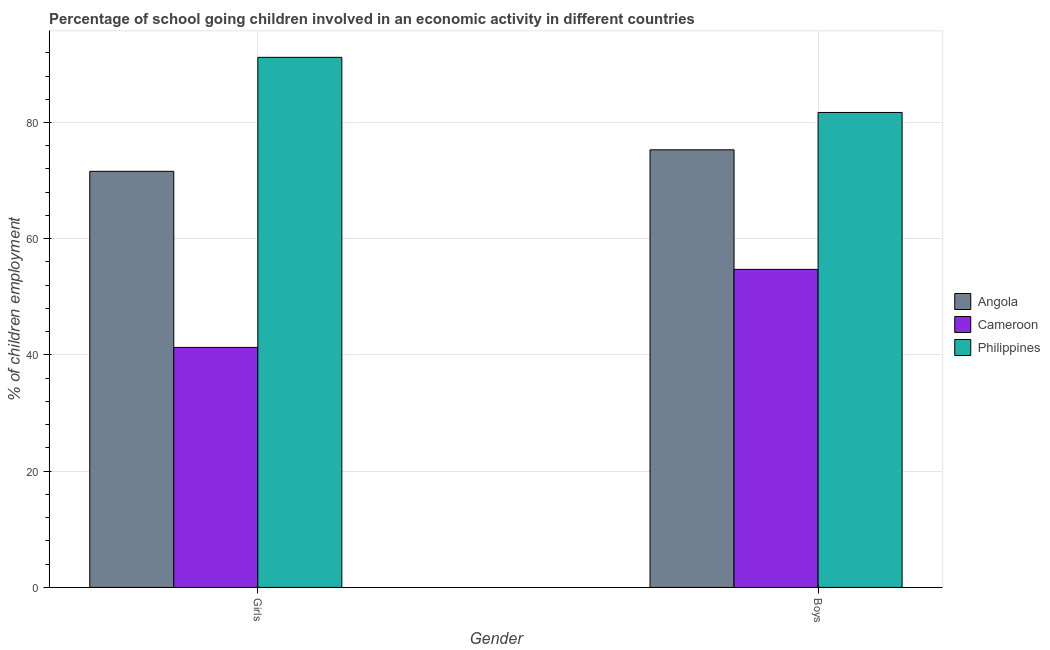How many different coloured bars are there?
Provide a short and direct response. 3. Are the number of bars per tick equal to the number of legend labels?
Your response must be concise. Yes. Are the number of bars on each tick of the X-axis equal?
Your response must be concise. Yes. How many bars are there on the 1st tick from the left?
Provide a short and direct response. 3. What is the label of the 2nd group of bars from the left?
Offer a terse response. Boys. What is the percentage of school going girls in Angola?
Your response must be concise. 71.6. Across all countries, what is the maximum percentage of school going girls?
Offer a very short reply. 91.21. Across all countries, what is the minimum percentage of school going boys?
Keep it short and to the point. 54.73. In which country was the percentage of school going boys minimum?
Give a very brief answer. Cameroon. What is the total percentage of school going boys in the graph?
Provide a succinct answer. 211.76. What is the difference between the percentage of school going boys in Philippines and that in Angola?
Give a very brief answer. 6.43. What is the difference between the percentage of school going boys in Angola and the percentage of school going girls in Cameroon?
Provide a succinct answer. 34. What is the average percentage of school going boys per country?
Your answer should be compact. 70.59. What is the difference between the percentage of school going boys and percentage of school going girls in Cameroon?
Keep it short and to the point. 13.43. What is the ratio of the percentage of school going boys in Cameroon to that in Angola?
Ensure brevity in your answer.  0.73. In how many countries, is the percentage of school going girls greater than the average percentage of school going girls taken over all countries?
Make the answer very short. 2. What does the 1st bar from the left in Boys represents?
Offer a terse response. Angola. What does the 3rd bar from the right in Girls represents?
Keep it short and to the point. Angola. Are all the bars in the graph horizontal?
Ensure brevity in your answer.  No. How many countries are there in the graph?
Make the answer very short. 3. Does the graph contain grids?
Provide a succinct answer. Yes. Where does the legend appear in the graph?
Keep it short and to the point. Center right. How many legend labels are there?
Provide a short and direct response. 3. How are the legend labels stacked?
Offer a terse response. Vertical. What is the title of the graph?
Ensure brevity in your answer.  Percentage of school going children involved in an economic activity in different countries. Does "Least developed countries" appear as one of the legend labels in the graph?
Provide a short and direct response. No. What is the label or title of the Y-axis?
Give a very brief answer. % of children employment. What is the % of children employment in Angola in Girls?
Provide a short and direct response. 71.6. What is the % of children employment in Cameroon in Girls?
Make the answer very short. 41.3. What is the % of children employment in Philippines in Girls?
Your response must be concise. 91.21. What is the % of children employment of Angola in Boys?
Your response must be concise. 75.3. What is the % of children employment of Cameroon in Boys?
Your answer should be compact. 54.73. What is the % of children employment of Philippines in Boys?
Ensure brevity in your answer.  81.73. Across all Gender, what is the maximum % of children employment of Angola?
Provide a succinct answer. 75.3. Across all Gender, what is the maximum % of children employment of Cameroon?
Offer a terse response. 54.73. Across all Gender, what is the maximum % of children employment of Philippines?
Keep it short and to the point. 91.21. Across all Gender, what is the minimum % of children employment in Angola?
Make the answer very short. 71.6. Across all Gender, what is the minimum % of children employment in Cameroon?
Provide a short and direct response. 41.3. Across all Gender, what is the minimum % of children employment in Philippines?
Offer a very short reply. 81.73. What is the total % of children employment in Angola in the graph?
Your answer should be very brief. 146.9. What is the total % of children employment in Cameroon in the graph?
Offer a terse response. 96.03. What is the total % of children employment of Philippines in the graph?
Your answer should be compact. 172.94. What is the difference between the % of children employment of Cameroon in Girls and that in Boys?
Keep it short and to the point. -13.43. What is the difference between the % of children employment in Philippines in Girls and that in Boys?
Give a very brief answer. 9.49. What is the difference between the % of children employment in Angola in Girls and the % of children employment in Cameroon in Boys?
Ensure brevity in your answer.  16.87. What is the difference between the % of children employment of Angola in Girls and the % of children employment of Philippines in Boys?
Your response must be concise. -10.13. What is the difference between the % of children employment in Cameroon in Girls and the % of children employment in Philippines in Boys?
Your answer should be compact. -40.43. What is the average % of children employment of Angola per Gender?
Keep it short and to the point. 73.45. What is the average % of children employment in Cameroon per Gender?
Offer a very short reply. 48.01. What is the average % of children employment in Philippines per Gender?
Provide a short and direct response. 86.47. What is the difference between the % of children employment in Angola and % of children employment in Cameroon in Girls?
Your answer should be very brief. 30.3. What is the difference between the % of children employment of Angola and % of children employment of Philippines in Girls?
Your answer should be compact. -19.61. What is the difference between the % of children employment of Cameroon and % of children employment of Philippines in Girls?
Ensure brevity in your answer.  -49.92. What is the difference between the % of children employment of Angola and % of children employment of Cameroon in Boys?
Provide a succinct answer. 20.57. What is the difference between the % of children employment in Angola and % of children employment in Philippines in Boys?
Your answer should be very brief. -6.43. What is the difference between the % of children employment in Cameroon and % of children employment in Philippines in Boys?
Provide a succinct answer. -27. What is the ratio of the % of children employment of Angola in Girls to that in Boys?
Offer a terse response. 0.95. What is the ratio of the % of children employment in Cameroon in Girls to that in Boys?
Your answer should be compact. 0.75. What is the ratio of the % of children employment of Philippines in Girls to that in Boys?
Your answer should be compact. 1.12. What is the difference between the highest and the second highest % of children employment of Angola?
Your answer should be compact. 3.7. What is the difference between the highest and the second highest % of children employment in Cameroon?
Keep it short and to the point. 13.43. What is the difference between the highest and the second highest % of children employment of Philippines?
Your answer should be compact. 9.49. What is the difference between the highest and the lowest % of children employment of Angola?
Give a very brief answer. 3.7. What is the difference between the highest and the lowest % of children employment of Cameroon?
Provide a succinct answer. 13.43. What is the difference between the highest and the lowest % of children employment in Philippines?
Keep it short and to the point. 9.49. 